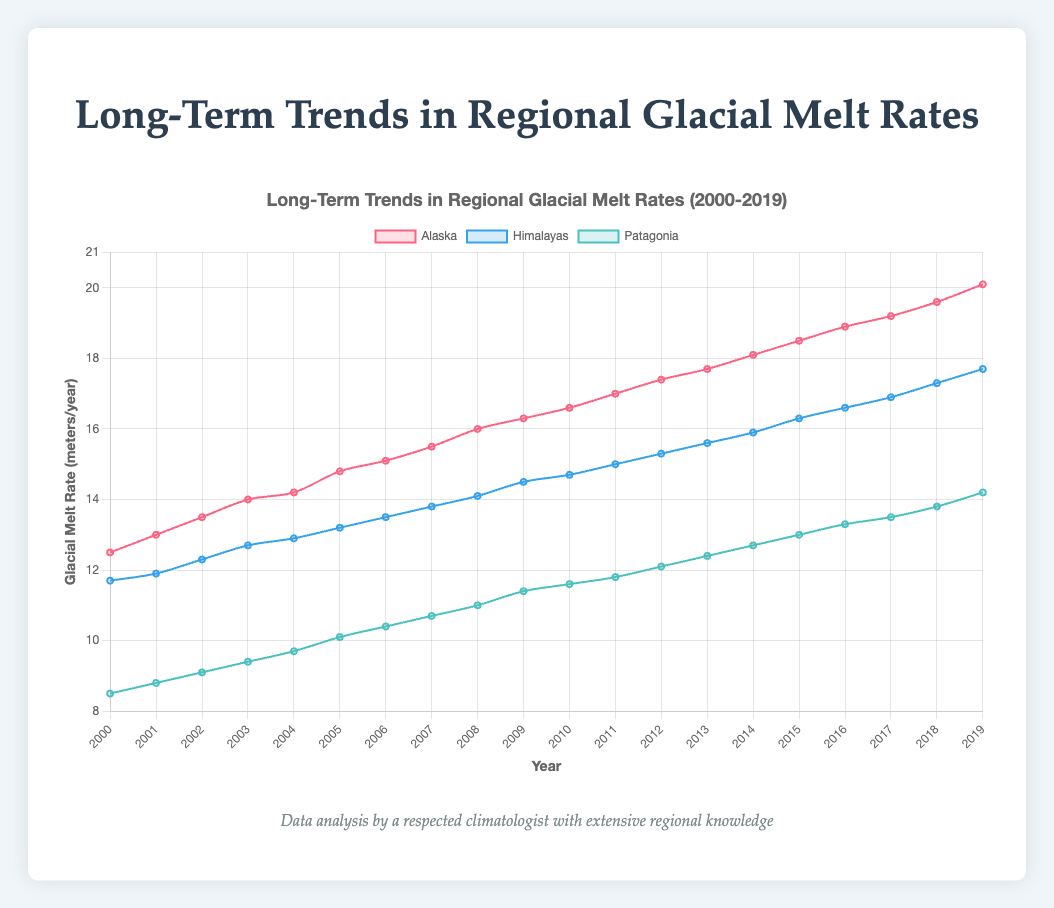What is the overall trend in glacial melt rates for Alaska from 2000 to 2019? The line plot shows a steady increase in the glacial melt rates for Alaska from 12.5 meters/year in 2000 to 20.1 meters/year in 2019. This indicates a consistent upward trend.
Answer: Increasing Which region had the highest glacial melt rate in 2019? By observing the height of the lines at the year 2019, Alaska has the highest glacial melt rate at 20.1 meters/year, followed by the Himalayas at 17.7 meters/year and Patagonia at 14.2 meters/year.
Answer: Alaska What is the difference in glacial melt rates between the Himalayas and Patagonia in 2010? The plot shows that in 2010, the Himalayas had a melt rate of 14.7 meters/year and Patagonia had a melt rate of 11.6 meters/year. The difference is calculated as 14.7 - 11.6 = 3.1 meters/year.
Answer: 3.1 meters/year Between which years did Alaska experience the highest increase in glacial melt rate? By observing the slope of the line for Alaska, the steepest slope appears between 2015 and 2016, where the glacial melt rate increased from 18.5 to 18.9 meters/year, a difference of 0.4 meters/year.
Answer: 2015-2016 What is the average glacial melt rate for the Himalayas over the first five years (2000-2004)? The glacial melt rates for the Himalayas from 2000-2004 are 11.7, 11.9, 12.3, 12.7, and 12.9 meters/year. The sum is 61.5, and dividing by 5 gives an average of 61.5 / 5 = 12.3 meters/year.
Answer: 12.3 meters/year How does the melt rate of Patagonia in 2005 compare to the melt rate in 2015? In 2005, Patagonia's melt rate was 10.1 meters/year, and in 2015, it was 13.0 meters/year. The melt rate increased by 13.0 - 10.1 = 2.9 meters/year over this decade.
Answer: Increased by 2.9 meters/year In which year did the Himalayas surpass a glacial melt rate of 15 meters/year? Observing the plot for the Himalayas, they surpass a melt rate of 15 meters/year in 2011 when the rate reaches exactly 15.0 meters/year. Therefore, the year they surpassed 15 meters/year is 2012.
Answer: 2012 Compare the trends in glacial melt rates for Alaska and the Himalayas. Both Alaska and the Himalayas show an upward trend in melt rates from 2000 to 2019. However, Alaska's glacial melt rates increase more sharply compared to the Himalayas.
Answer: Alaska’s trend is sharper What is the sum of the glacial melt rates for Patagonia and the Himalayas in the year 2000? The melt rate for Patagonia in 2000 is 8.5 meters/year and for the Himalayas is 11.7 meters/year. Summing these gives 8.5 + 11.7 = 20.2 meters/year.
Answer: 20.2 meters/year 